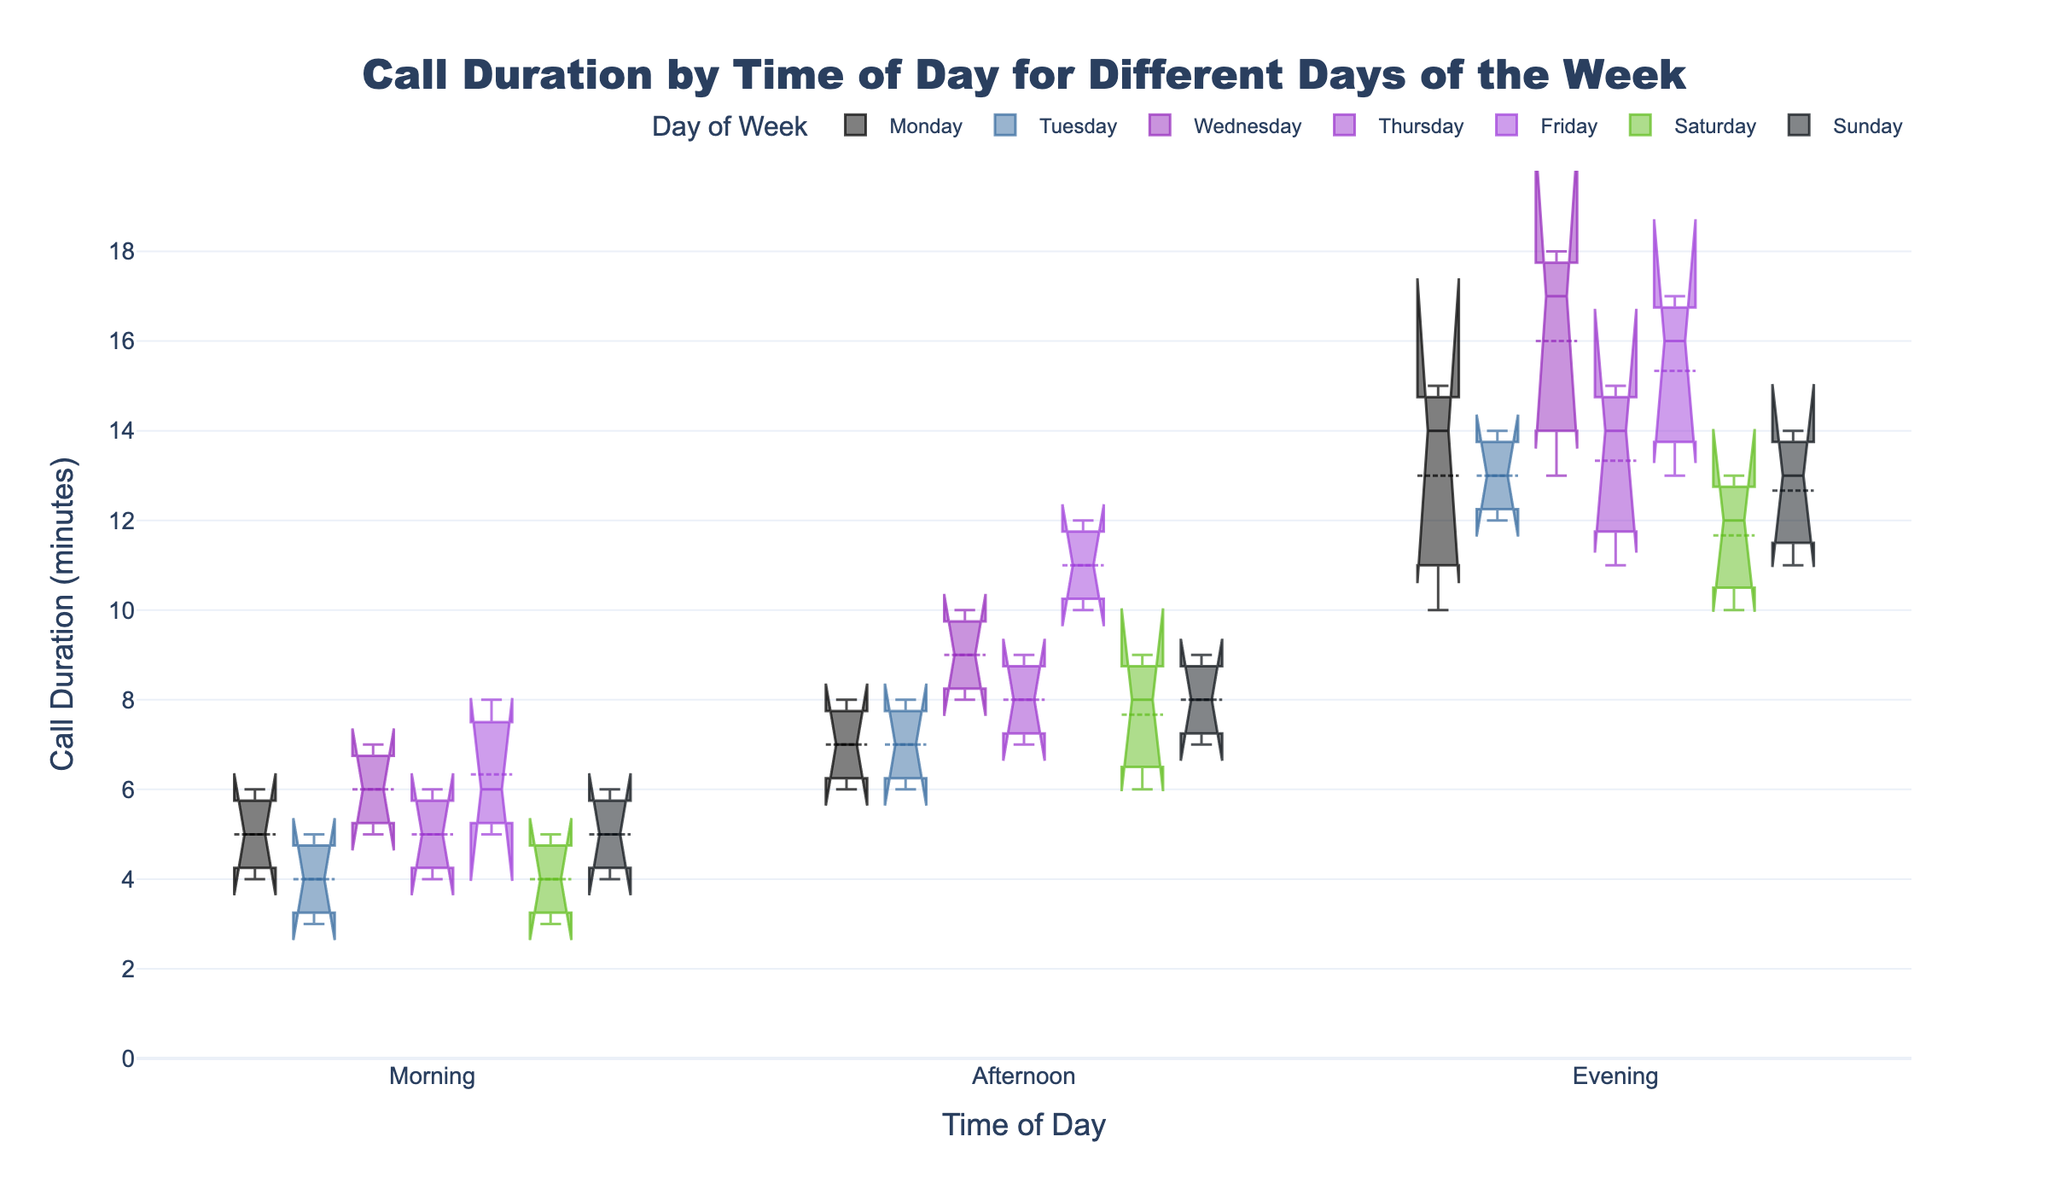What is the title of the plot? The title is usually displayed at the top center of the plot. According to the data snippet and code, the specified title is "Call Duration by Time of Day for Different Days of the Week".
Answer: Call Duration by Time of Day for Different Days of the Week Which day has the highest median call duration in the evening? To find this, look at the position of the median lines (inside the notch) in the evening category for each day. The highest median line indicates the highest median call duration.
Answer: Wednesday During which time of day is the variance in call duration the highest for Friday? The variance is related to the spread of the box and whiskers. The larger the box and whiskers, the higher the variance.
Answer: Evening What is the median call duration on Tuesday mornings? The median is indicated by the notch in the box plot. For Tuesday mornings, locate the notch and read the value from the y-axis.
Answer: 4 minutes Which day has the least variation in call duration in the afternoon? Variation can be estimated by looking at the box's interquartile range (IQR) and whiskers. The day with the smallest IQR and whiskers in the afternoon has the least variation.
Answer: Sunday Compare the median call duration for mornings and afternoons on Monday. Which one is higher? Find the notches (medians) for Monday mornings and afternoons and compare their y-axis values.
Answer: Afternoon On which day is the difference between the highest and lowest call duration in the evening the greatest? To determine this, compare the lengths of the whiskers (representing the range) for each day in the evening category. The day with the longest whiskers has the greatest difference.
Answer: Wednesday What is the general trend of call duration from morning to evening for Thursday? Examine the position of the medians (notches) from morning to evening on Thursday to observe if they increase, decrease, or remain consistent.
Answer: Increases Which day of the week shows the highest median call duration overall? Compare the notches of the boxes across all days and times of the day to see which day consistently has a higher median.
Answer: Wednesday 